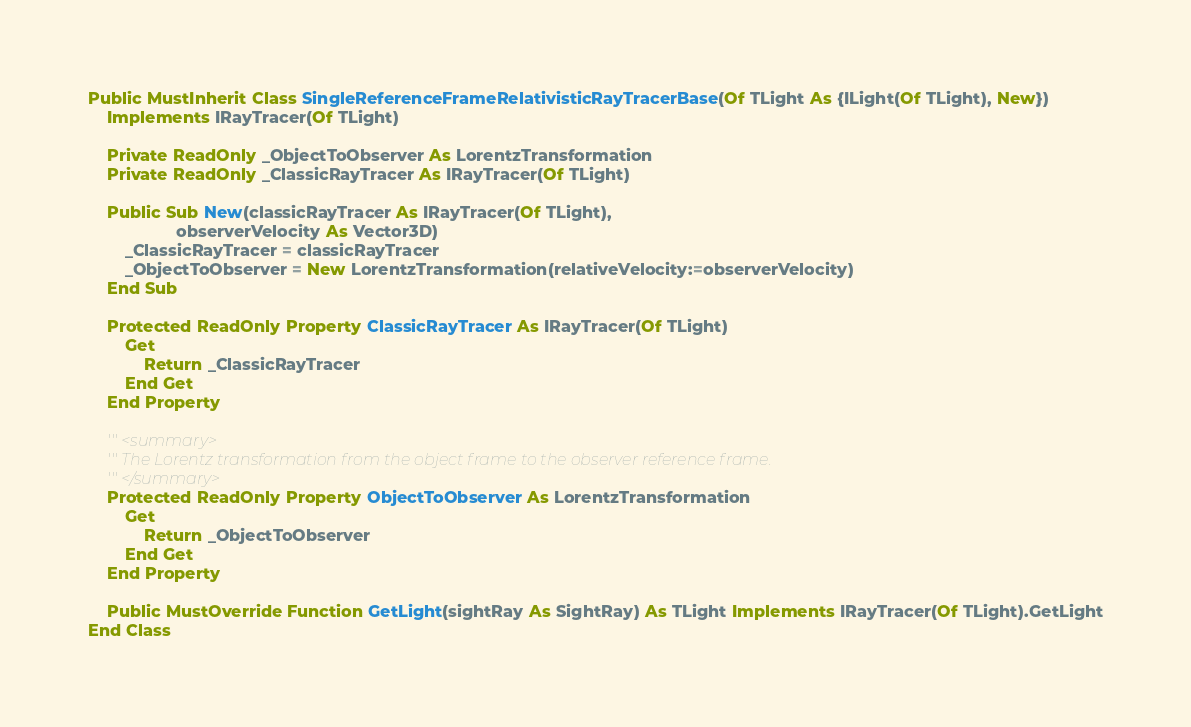Convert code to text. <code><loc_0><loc_0><loc_500><loc_500><_VisualBasic_>Public MustInherit Class SingleReferenceFrameRelativisticRayTracerBase(Of TLight As {ILight(Of TLight), New})
    Implements IRayTracer(Of TLight)

    Private ReadOnly _ObjectToObserver As LorentzTransformation
    Private ReadOnly _ClassicRayTracer As IRayTracer(Of TLight)

    Public Sub New(classicRayTracer As IRayTracer(Of TLight),
                   observerVelocity As Vector3D)
        _ClassicRayTracer = classicRayTracer
        _ObjectToObserver = New LorentzTransformation(relativeVelocity:=observerVelocity)
    End Sub

    Protected ReadOnly Property ClassicRayTracer As IRayTracer(Of TLight)
        Get
            Return _ClassicRayTracer
        End Get
    End Property

    ''' <summary>
    ''' The Lorentz transformation from the object frame to the observer reference frame.
    ''' </summary>
    Protected ReadOnly Property ObjectToObserver As LorentzTransformation
        Get
            Return _ObjectToObserver
        End Get
    End Property

    Public MustOverride Function GetLight(sightRay As SightRay) As TLight Implements IRayTracer(Of TLight).GetLight
End Class
</code> 